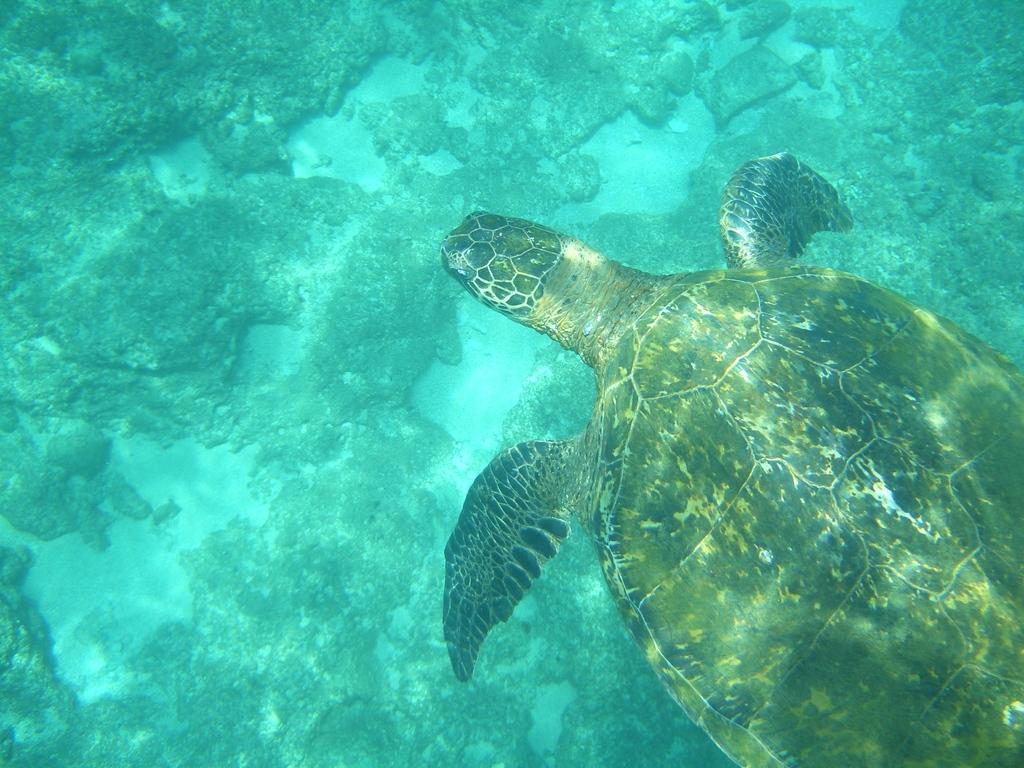What animal can be seen in the water in the image? There is a turtle in the water in the image. What type of environment is depicted in the image? The image shows a water environment with rocks and sand visible. Can you describe the water in the image? Yes, there is water visible in the image. What type of terrain is present in the image? Rocks and sand are present in the image. What type of bomb can be seen in the image? There is no bomb present in the image; it features a turtle in the water with rocks and sand visible. Can you describe the kiss between the two turtles in the image? There are no turtles kissing in the image; it only shows one turtle in the water. 